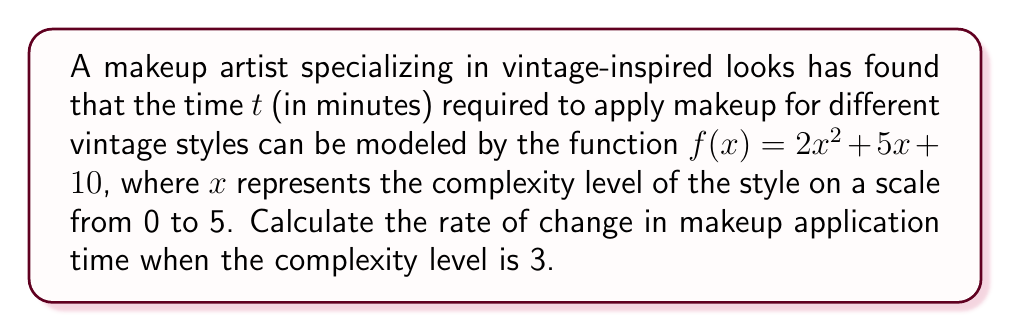Can you answer this question? To find the rate of change in makeup application time at a specific complexity level, we need to calculate the derivative of the given function and evaluate it at the given point.

Step 1: Identify the function
$f(x) = 2x^2 + 5x + 10$

Step 2: Calculate the derivative
Using the power rule and constant rule:
$$\frac{d}{dx}(2x^2) = 2 \cdot 2x = 4x$$
$$\frac{d}{dx}(5x) = 5$$
$$\frac{d}{dx}(10) = 0$$

Combining these results:
$$f'(x) = 4x + 5$$

Step 3: Evaluate the derivative at $x = 3$
$$f'(3) = 4(3) + 5 = 12 + 5 = 17$$

Therefore, when the complexity level is 3, the rate of change in makeup application time is 17 minutes per unit of complexity.
Answer: 17 minutes per unit of complexity 